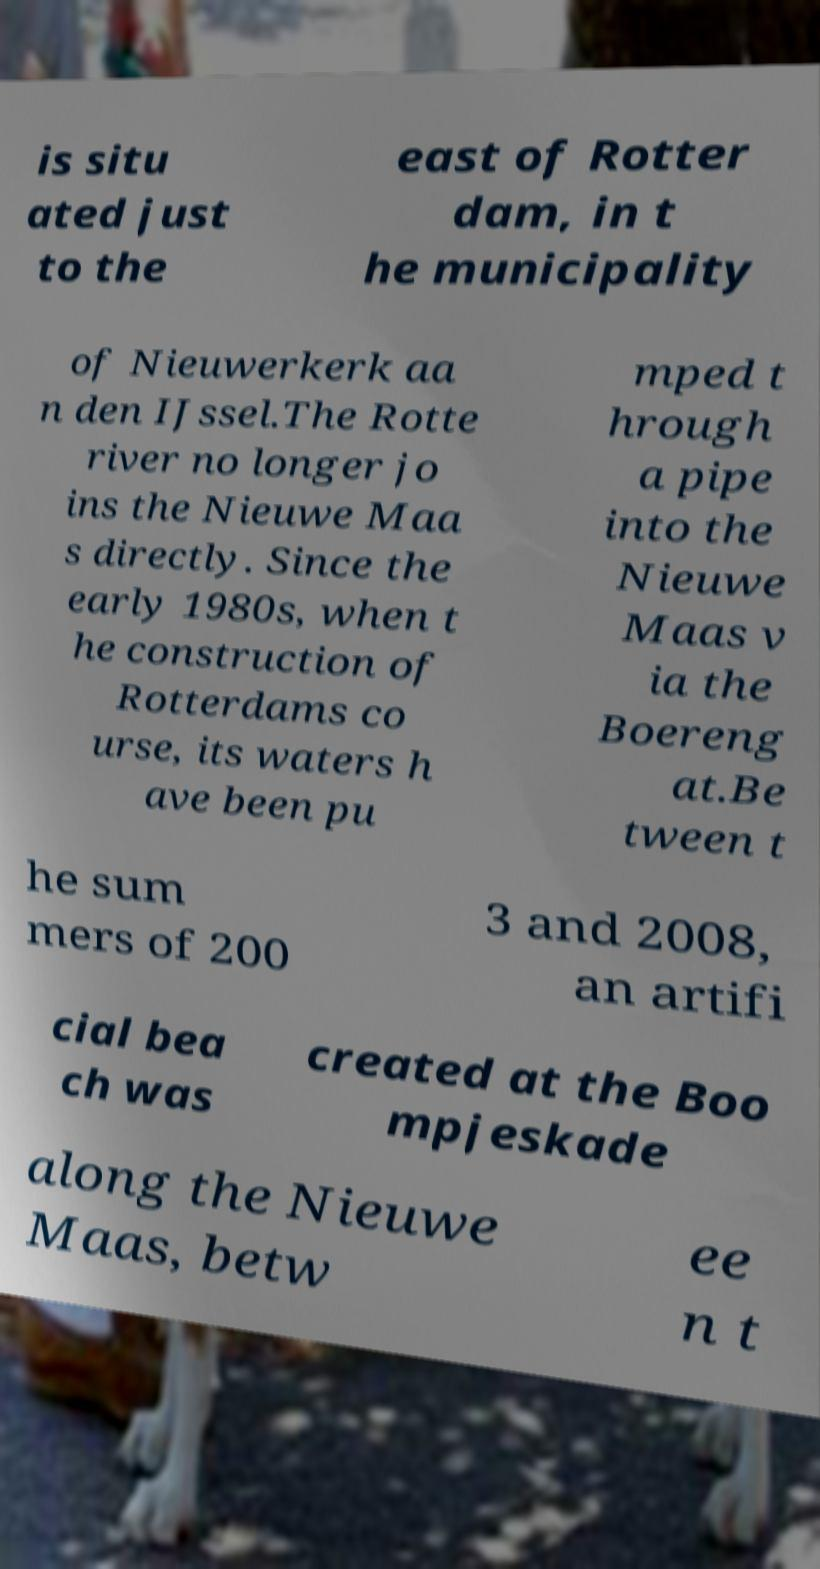There's text embedded in this image that I need extracted. Can you transcribe it verbatim? is situ ated just to the east of Rotter dam, in t he municipality of Nieuwerkerk aa n den IJssel.The Rotte river no longer jo ins the Nieuwe Maa s directly. Since the early 1980s, when t he construction of Rotterdams co urse, its waters h ave been pu mped t hrough a pipe into the Nieuwe Maas v ia the Boereng at.Be tween t he sum mers of 200 3 and 2008, an artifi cial bea ch was created at the Boo mpjeskade along the Nieuwe Maas, betw ee n t 